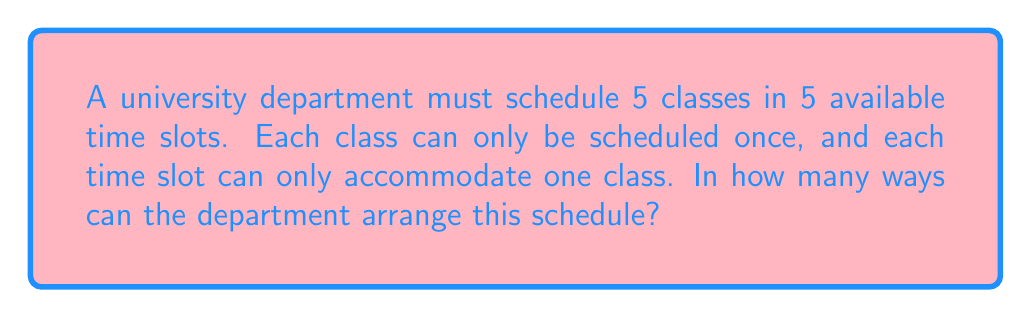Solve this math problem. Let us approach this problem step-by-step, my dear students.

1) First, we must recognize that this is a permutation problem. We are arranging 5 distinct classes into 5 distinct time slots, with no repetitions allowed.

2) The fundamental principle of permutations tells us that when we have n distinct objects to arrange in n distinct positions, the number of possible arrangements is given by n!.

3) In this case, n = 5, as we have 5 classes to arrange in 5 time slots.

4) Therefore, the number of possible arrangements is 5!.

5) Let's calculate this:
   
   $$5! = 5 \times 4 \times 3 \times 2 \times 1 = 120$$

6) To understand why this works, let's think about the process:
   - For the first time slot, we have 5 choices of classes.
   - For the second time slot, we now have 4 remaining choices.
   - For the third, 3 choices remain.
   - For the fourth, we're down to 2 choices.
   - For the last time slot, only 1 class remains.

7) Multiplying these choices together gives us 5 x 4 x 3 x 2 x 1 = 120.

Thus, there are 120 possible ways to arrange the class schedule.
Answer: 120 